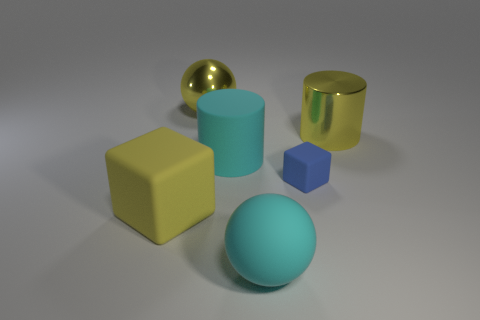Are there more yellow rubber blocks in front of the large shiny ball than tiny spheres?
Provide a short and direct response. Yes. What number of things are either cyan spheres right of the yellow metal ball or matte things on the left side of the blue block?
Your answer should be compact. 3. What is the size of the blue cube that is the same material as the cyan ball?
Keep it short and to the point. Small. Does the large yellow thing that is in front of the big yellow cylinder have the same shape as the small blue object?
Provide a short and direct response. Yes. There is a metal ball that is the same color as the shiny cylinder; what is its size?
Give a very brief answer. Large. What number of yellow objects are either metallic objects or tiny rubber objects?
Keep it short and to the point. 2. What is the shape of the large rubber thing that is on the right side of the large yellow matte thing and left of the cyan ball?
Give a very brief answer. Cylinder. There is a cyan ball; are there any yellow rubber things right of it?
Give a very brief answer. No. There is another matte thing that is the same shape as the large yellow rubber thing; what size is it?
Make the answer very short. Small. Is there any other thing that is the same size as the blue matte thing?
Make the answer very short. No. 